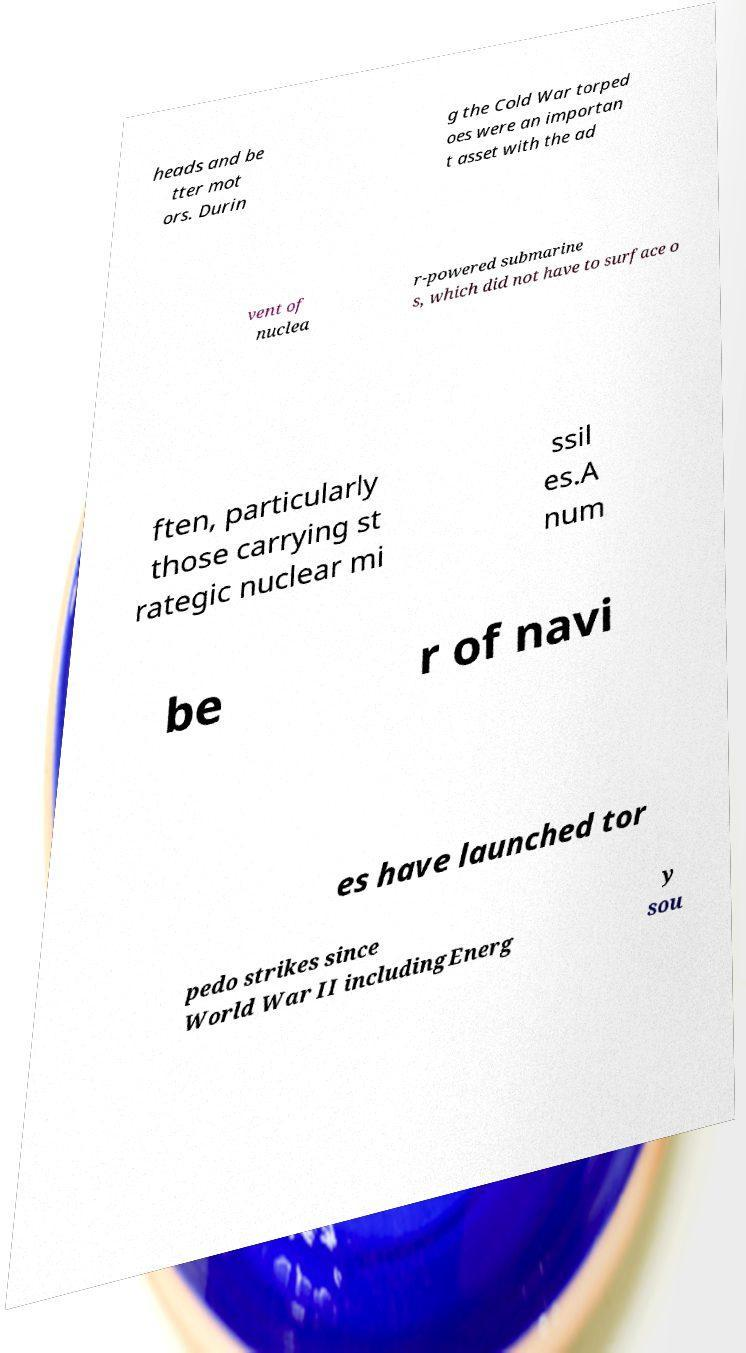Can you accurately transcribe the text from the provided image for me? heads and be tter mot ors. Durin g the Cold War torped oes were an importan t asset with the ad vent of nuclea r-powered submarine s, which did not have to surface o ften, particularly those carrying st rategic nuclear mi ssil es.A num be r of navi es have launched tor pedo strikes since World War II includingEnerg y sou 